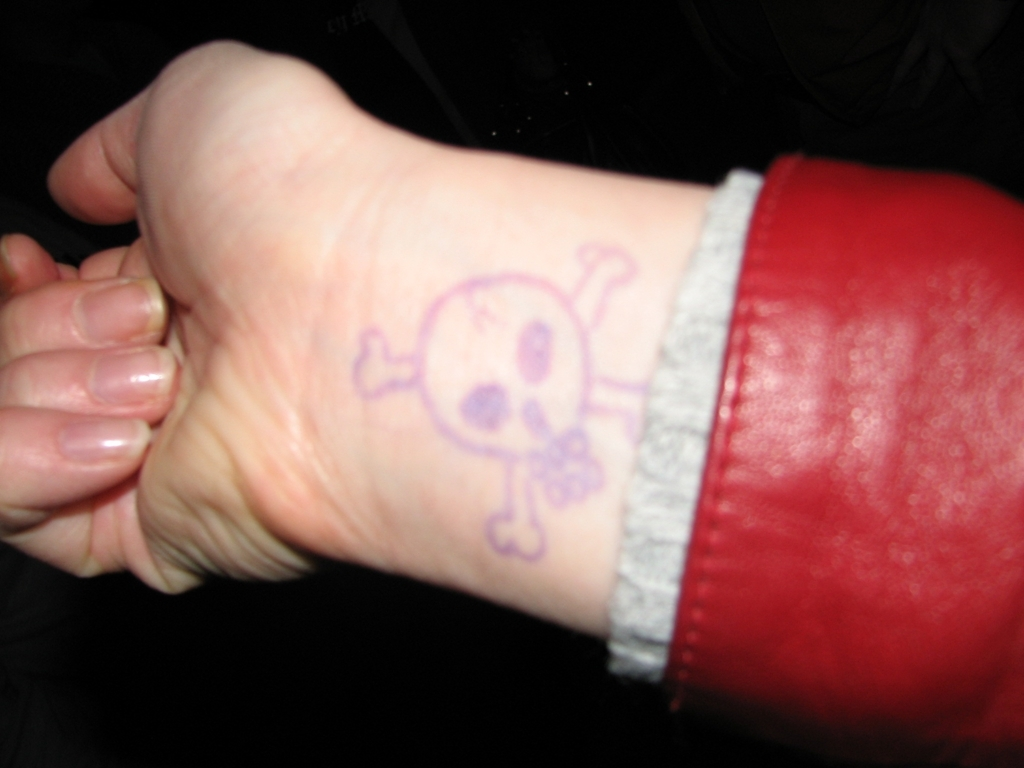What can you infer about the person's style or personality based on this image? The individual seems to prefer a bold expression, as indicated by the visible skull and crossbones image on their wrist, which can signify a rebellious or daring personality trait. Additionally, the red garment suggests a vibrant and possibly adventurous fashion sense. However, without more context, these inferences are speculative. Is there anything else visible that might provide more insights about the individual? Apart from the distinct symbol on the wrist and the red article of clothing, there are limited visual cues to draw further conclusions. The hands appear well-kept, suggesting attention to grooming. Nonetheless, without additional visual information, it's challenging to construct a complete personality or style profile. 